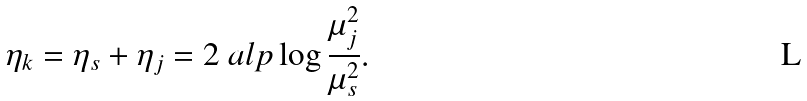<formula> <loc_0><loc_0><loc_500><loc_500>\eta _ { k } = \eta _ { s } + \eta _ { j } = 2 \ a l p \log \frac { \mu _ { j } ^ { 2 } } { \mu _ { s } ^ { 2 } } .</formula> 